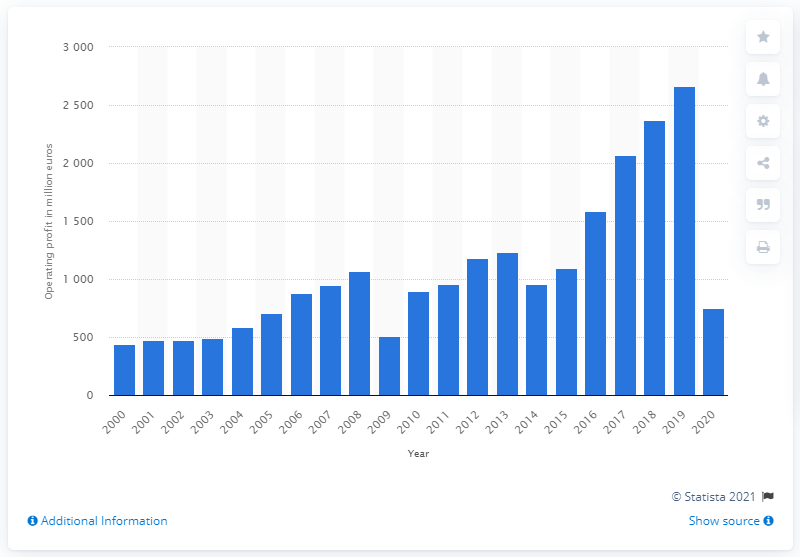Specify some key components in this picture. In 2020, the worldwide operating profit was 751. 